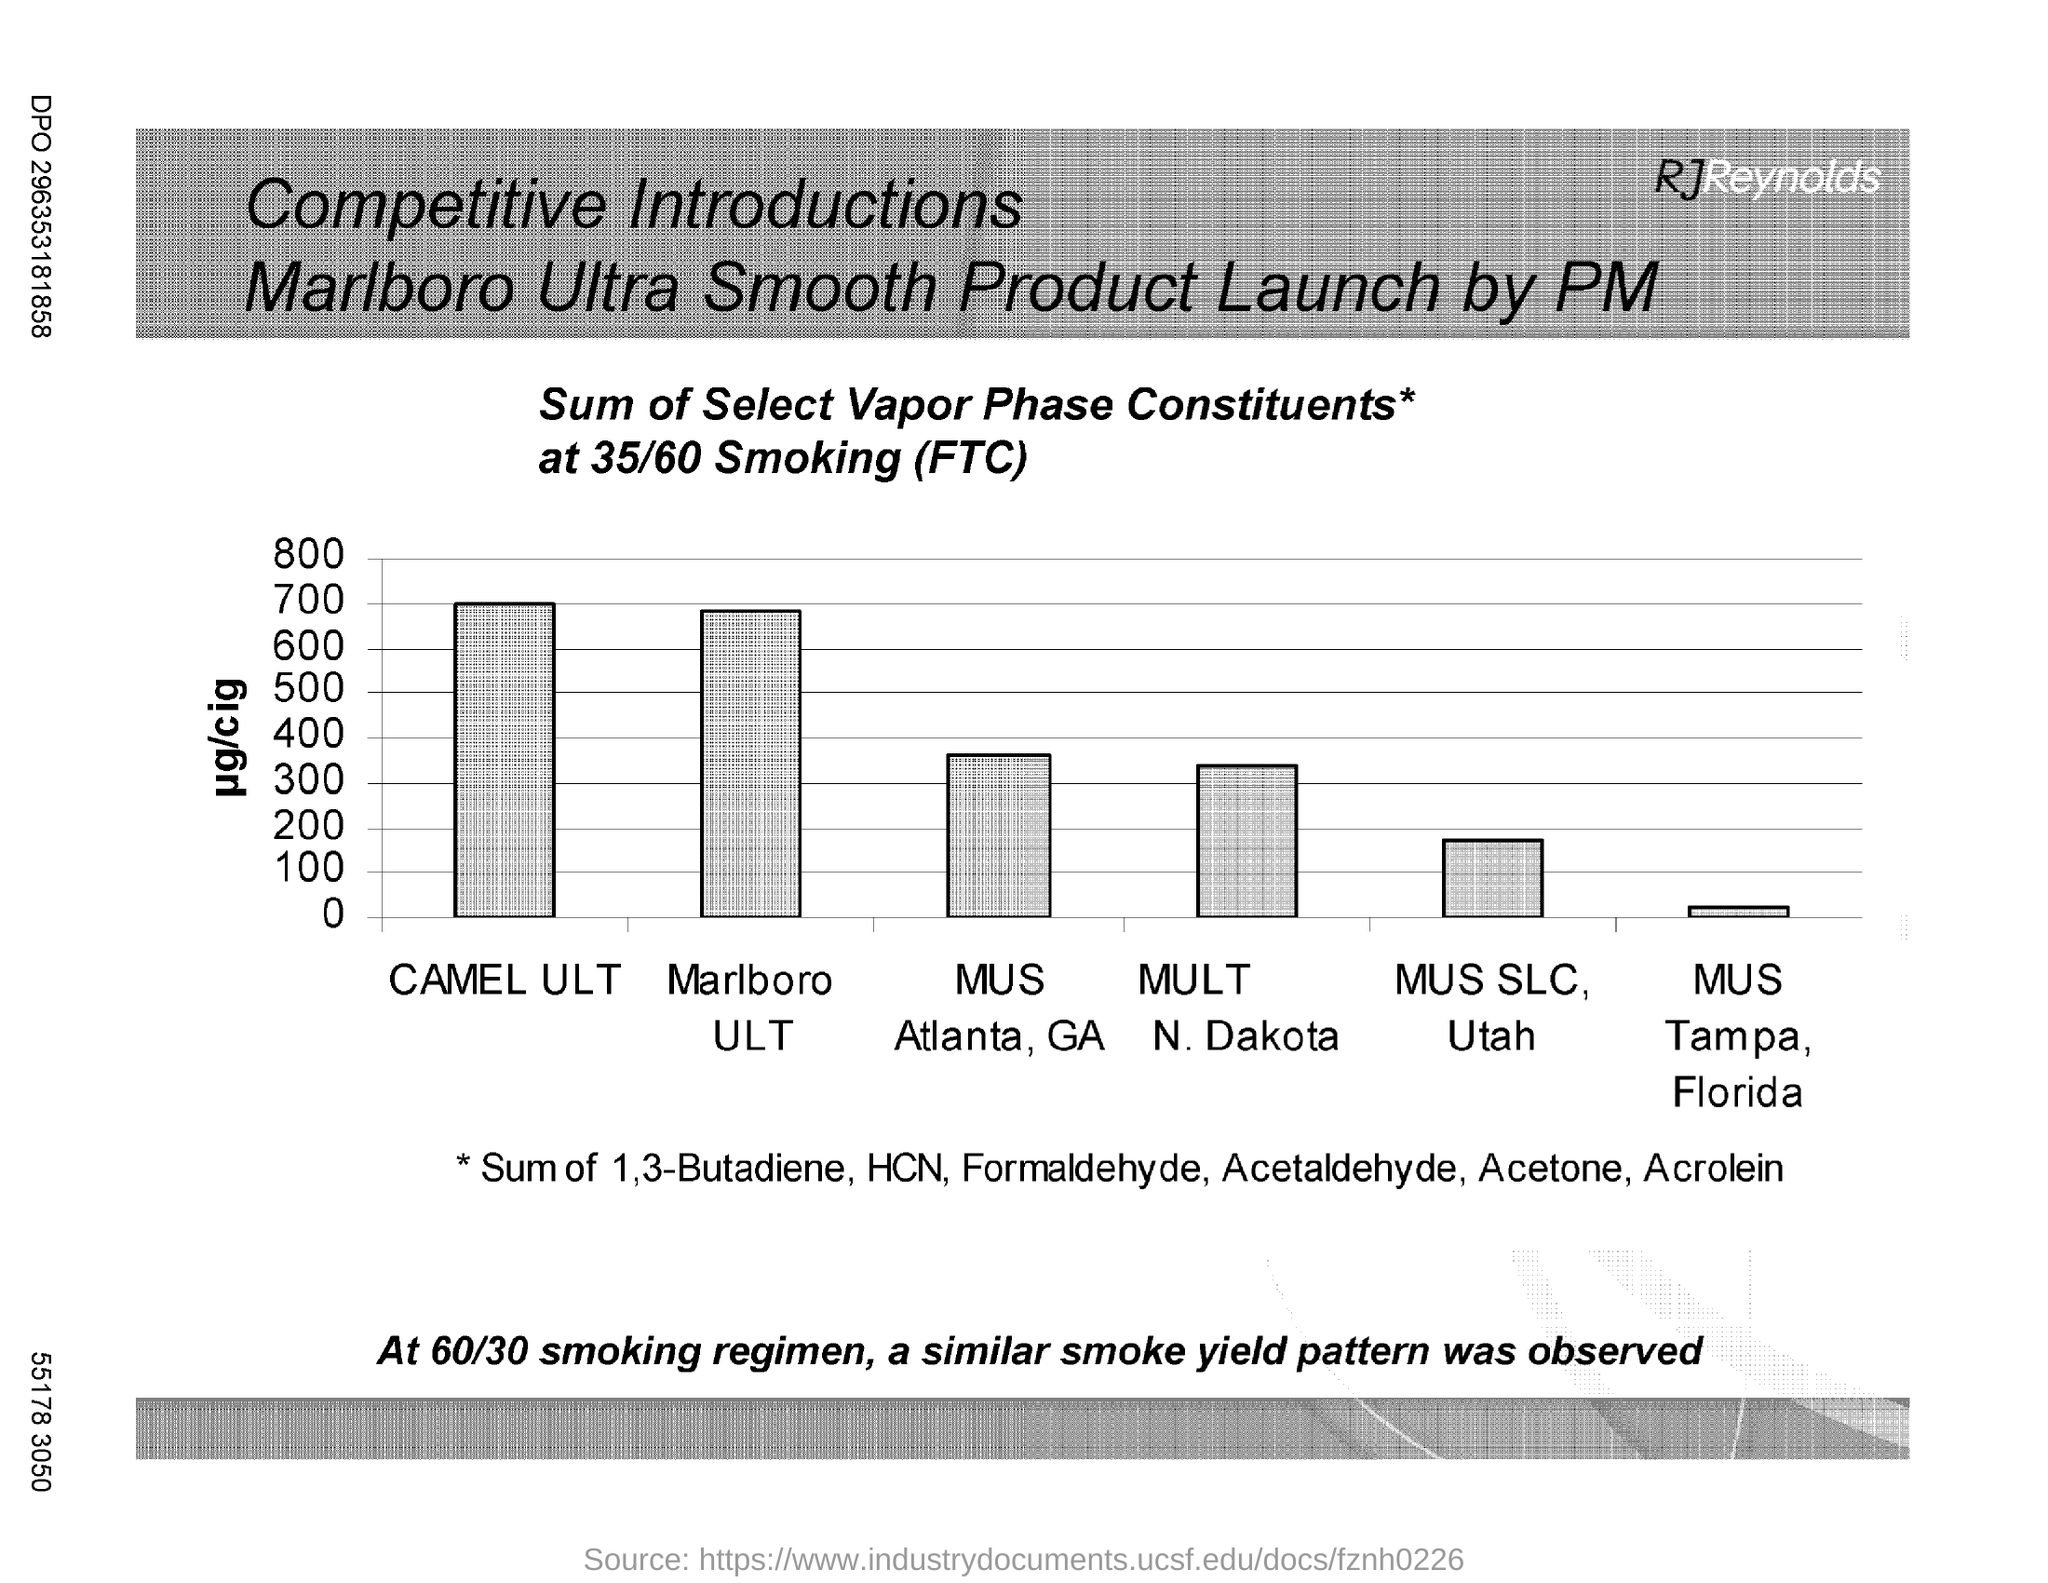Give some essential details in this illustration. The maximum value plotted on the Y-axis is 800. The minimum value in the Y axis is 0, and the range is from 0 to 100. Can you provide the value for 'CAMEL ULT'? It's 700... 